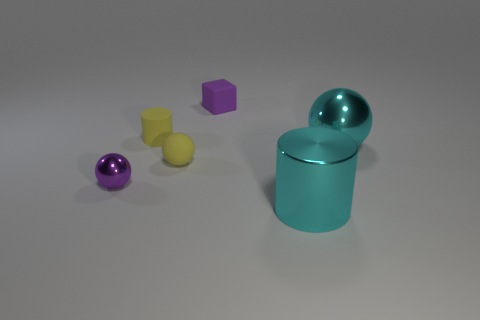What number of tiny balls are the same color as the rubber cylinder?
Provide a short and direct response. 1. Is the number of matte blocks greater than the number of yellow rubber objects?
Provide a succinct answer. No. Are there any small cyan things that have the same shape as the purple shiny object?
Provide a short and direct response. No. There is a metallic object in front of the small metal object; what is its shape?
Offer a terse response. Cylinder. There is a tiny matte thing left of the small rubber thing that is in front of the yellow cylinder; how many metal objects are in front of it?
Make the answer very short. 3. Is the color of the large object that is in front of the yellow rubber sphere the same as the matte block?
Your answer should be very brief. No. How many other objects are the same shape as the purple rubber object?
Offer a very short reply. 0. How many other objects are the same material as the tiny purple sphere?
Ensure brevity in your answer.  2. What is the yellow object that is behind the shiny ball to the right of the metal sphere on the left side of the large metallic ball made of?
Provide a succinct answer. Rubber. Do the small cylinder and the purple ball have the same material?
Provide a short and direct response. No. 